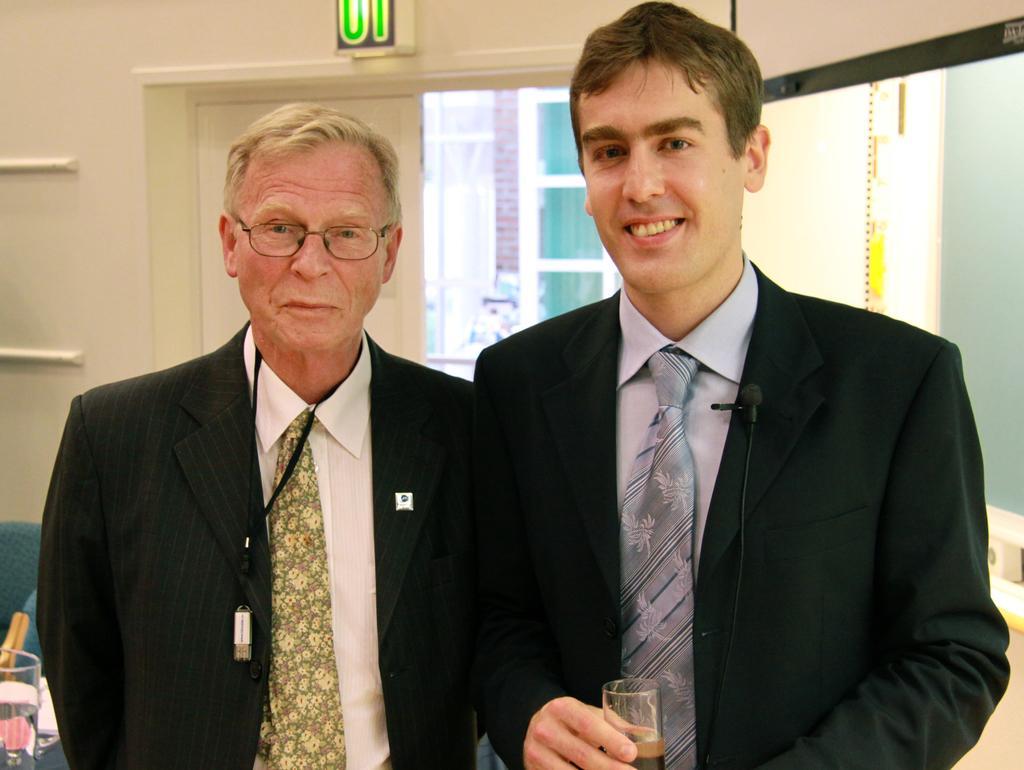Can you describe this image briefly? This image is taken indoors. In the background there is a wall with a window and a mirror. In the middle of the image two men are standing on the floor and a man is holding a glass in his hand. On the left side of the image there is a table with a few things on it and there is an empty chair. 